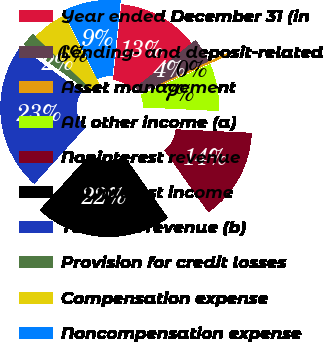<chart> <loc_0><loc_0><loc_500><loc_500><pie_chart><fcel>Year ended December 31 (in<fcel>Lending- and deposit-related<fcel>Asset management<fcel>All other income (a)<fcel>Noninterest revenue<fcel>Net interest income<fcel>Total net revenue (b)<fcel>Provision for credit losses<fcel>Compensation expense<fcel>Noncompensation expense<nl><fcel>12.66%<fcel>3.79%<fcel>0.24%<fcel>7.34%<fcel>14.44%<fcel>21.53%<fcel>23.31%<fcel>2.01%<fcel>5.56%<fcel>9.11%<nl></chart> 